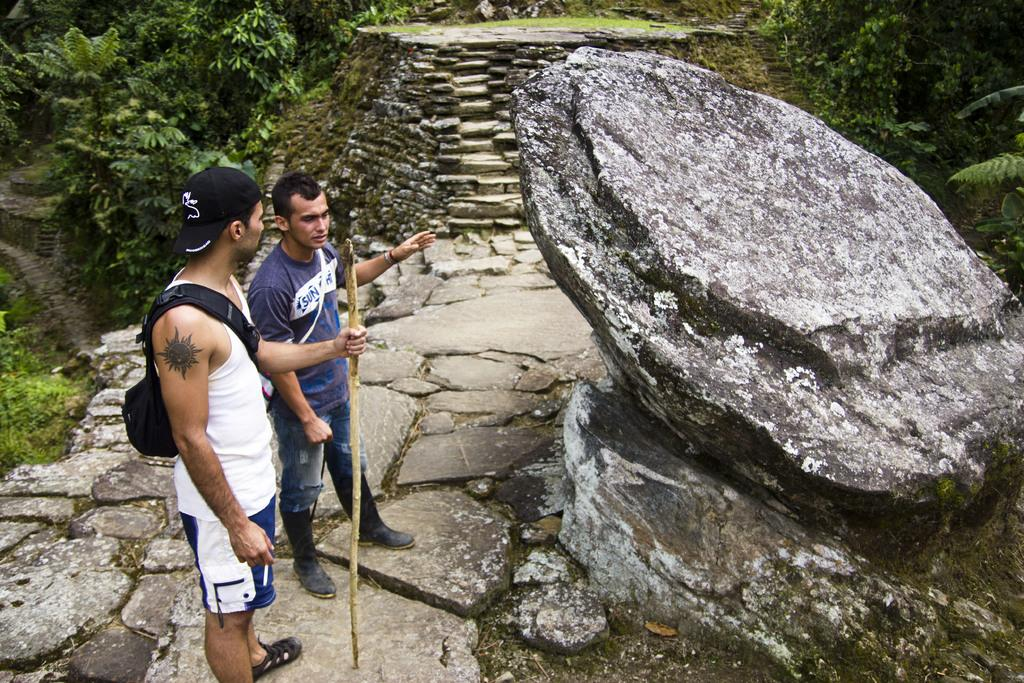How many people are present in the image? There are two persons standing in the image. What is one of the persons holding in the image? There is a person holding a stick in the image. What can be seen in the background of the image? There are plants, grass, and rocks in the background of the image. What type of gold apparel is the person wearing in the image? There is no gold apparel present in the image. Is there a ball visible in the image? There is no ball visible in the image. 